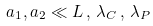Convert formula to latex. <formula><loc_0><loc_0><loc_500><loc_500>a _ { 1 } , a _ { 2 } \ll L \, , \, \lambda _ { C } \, , \, \lambda _ { P }</formula> 